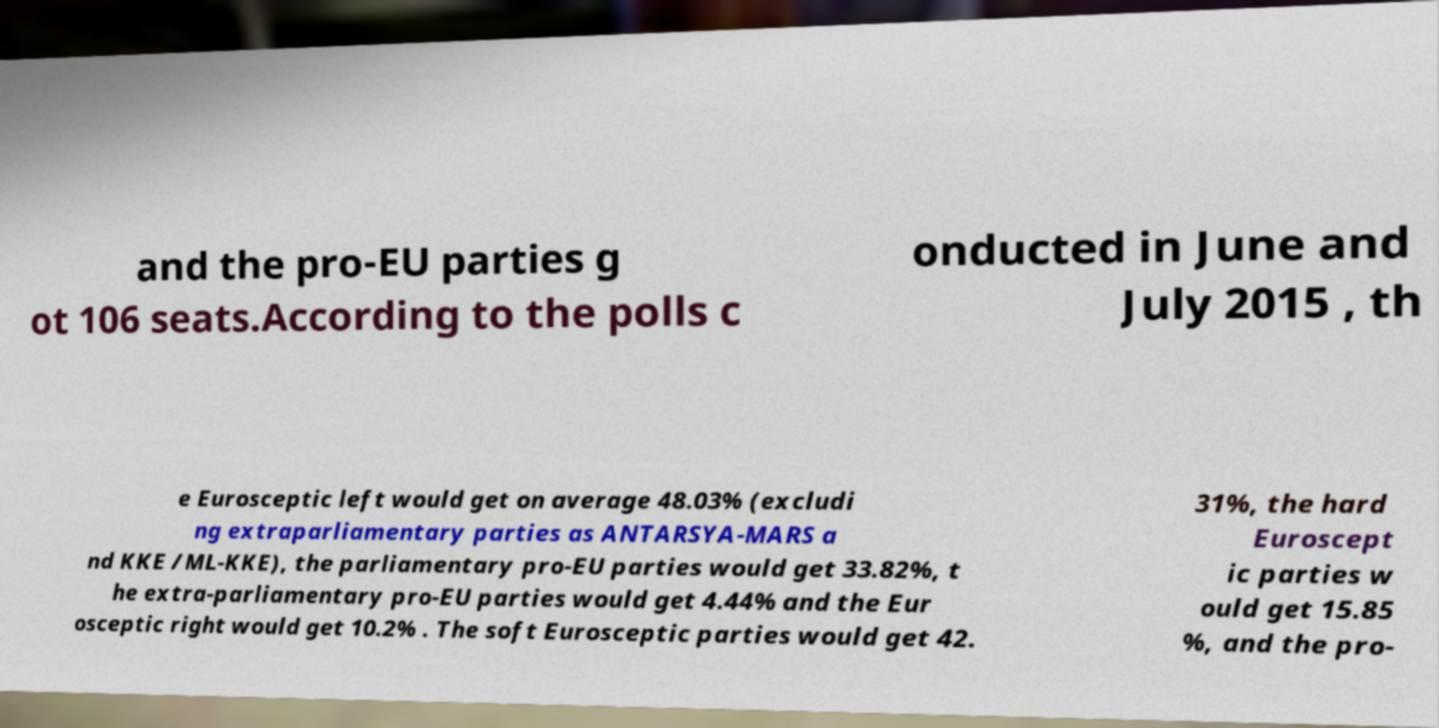There's text embedded in this image that I need extracted. Can you transcribe it verbatim? and the pro-EU parties g ot 106 seats.According to the polls c onducted in June and July 2015 , th e Eurosceptic left would get on average 48.03% (excludi ng extraparliamentary parties as ANTARSYA-MARS a nd KKE /ML-KKE), the parliamentary pro-EU parties would get 33.82%, t he extra-parliamentary pro-EU parties would get 4.44% and the Eur osceptic right would get 10.2% . The soft Eurosceptic parties would get 42. 31%, the hard Euroscept ic parties w ould get 15.85 %, and the pro- 